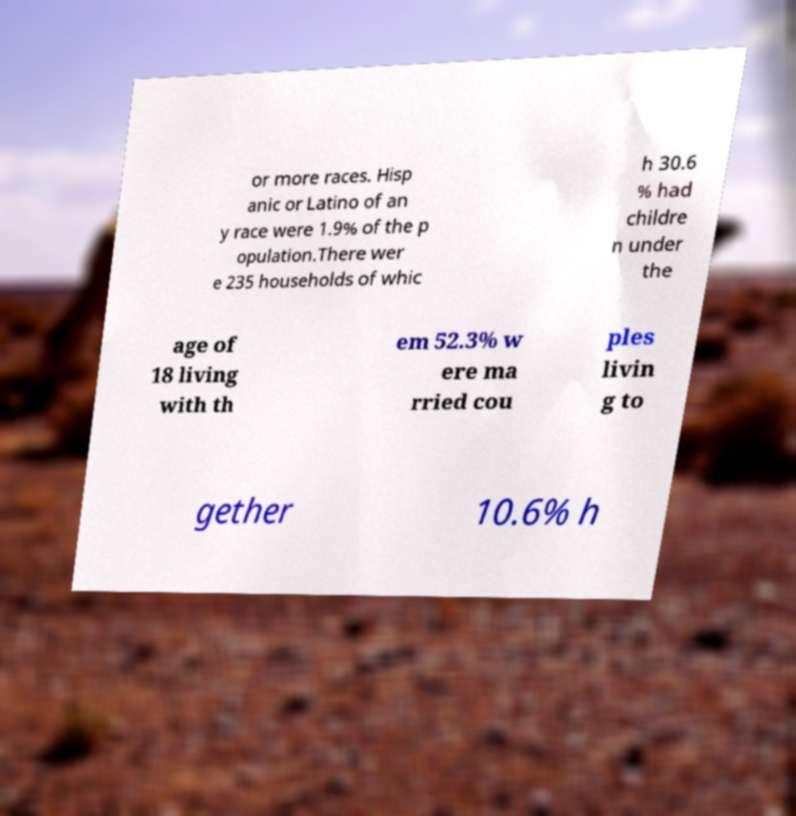For documentation purposes, I need the text within this image transcribed. Could you provide that? or more races. Hisp anic or Latino of an y race were 1.9% of the p opulation.There wer e 235 households of whic h 30.6 % had childre n under the age of 18 living with th em 52.3% w ere ma rried cou ples livin g to gether 10.6% h 